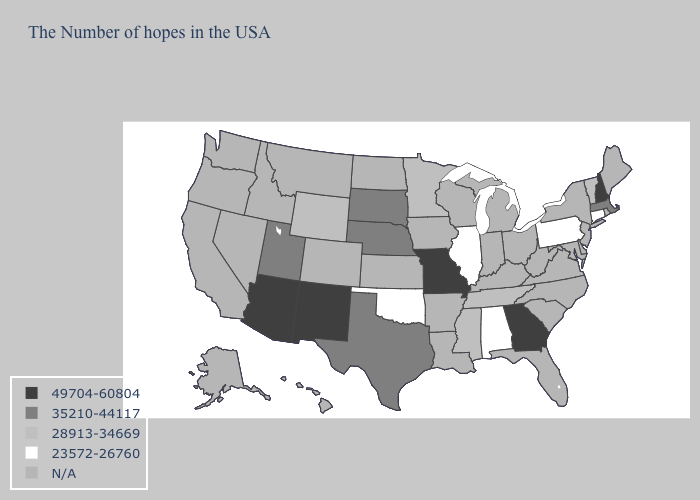Name the states that have a value in the range 23572-26760?
Quick response, please. Connecticut, Pennsylvania, Alabama, Illinois, Oklahoma. Name the states that have a value in the range 35210-44117?
Short answer required. Massachusetts, Nebraska, Texas, South Dakota, Utah. Which states hav the highest value in the MidWest?
Give a very brief answer. Missouri. Is the legend a continuous bar?
Quick response, please. No. Name the states that have a value in the range 28913-34669?
Be succinct. Vermont, Tennessee, Mississippi, Minnesota, Wyoming. Which states have the lowest value in the USA?
Keep it brief. Connecticut, Pennsylvania, Alabama, Illinois, Oklahoma. Does the first symbol in the legend represent the smallest category?
Quick response, please. No. What is the highest value in states that border Kansas?
Keep it brief. 49704-60804. Name the states that have a value in the range 35210-44117?
Short answer required. Massachusetts, Nebraska, Texas, South Dakota, Utah. Does New Mexico have the highest value in the USA?
Keep it brief. Yes. Does New Hampshire have the lowest value in the Northeast?
Quick response, please. No. What is the value of Hawaii?
Be succinct. N/A. 